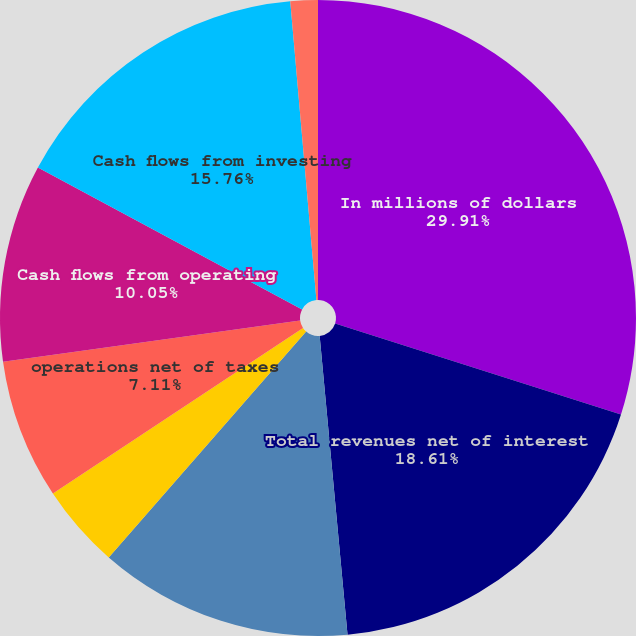Convert chart to OTSL. <chart><loc_0><loc_0><loc_500><loc_500><pie_chart><fcel>In millions of dollars<fcel>Total revenues net of interest<fcel>operations<fcel>Benefit for income taxes<fcel>operations net of taxes<fcel>Cash flows from operating<fcel>Cash flows from investing<fcel>discontinued operations<nl><fcel>29.91%<fcel>18.61%<fcel>12.91%<fcel>4.26%<fcel>7.11%<fcel>10.05%<fcel>15.76%<fcel>1.39%<nl></chart> 